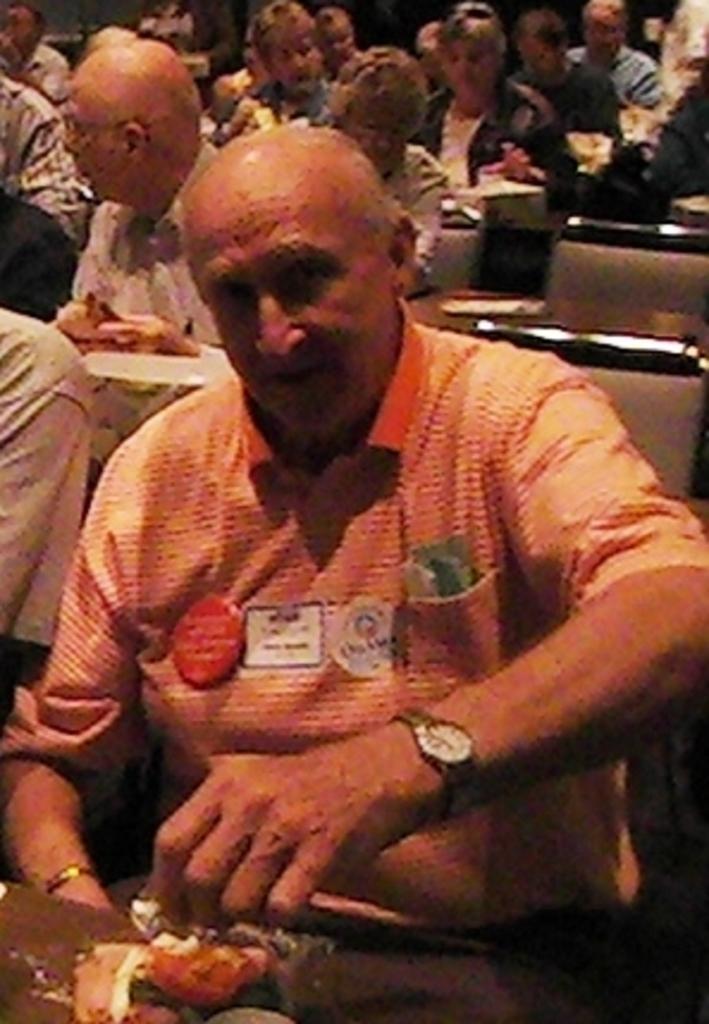Could you give a brief overview of what you see in this image? The picture is taken inside a room. There are many tables and chairs. On the chairs people are sitting. In the foreground an old man is sitting. There are badges on his shirt. On the table there are papers and few other things. 